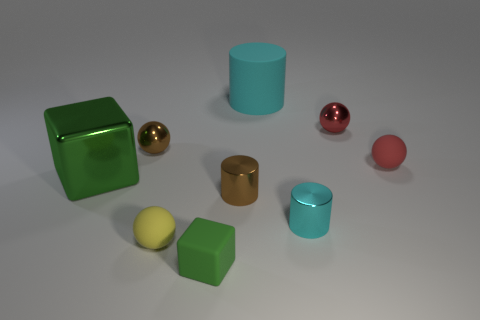Subtract all large cylinders. How many cylinders are left? 2 Subtract all brown cylinders. How many cylinders are left? 2 Subtract all balls. How many objects are left? 5 Subtract 2 cylinders. How many cylinders are left? 1 Subtract all green cylinders. How many yellow balls are left? 1 Subtract all large cubes. Subtract all tiny green blocks. How many objects are left? 7 Add 6 red rubber spheres. How many red rubber spheres are left? 7 Add 3 rubber things. How many rubber things exist? 7 Subtract 0 purple cylinders. How many objects are left? 9 Subtract all red balls. Subtract all yellow cubes. How many balls are left? 2 